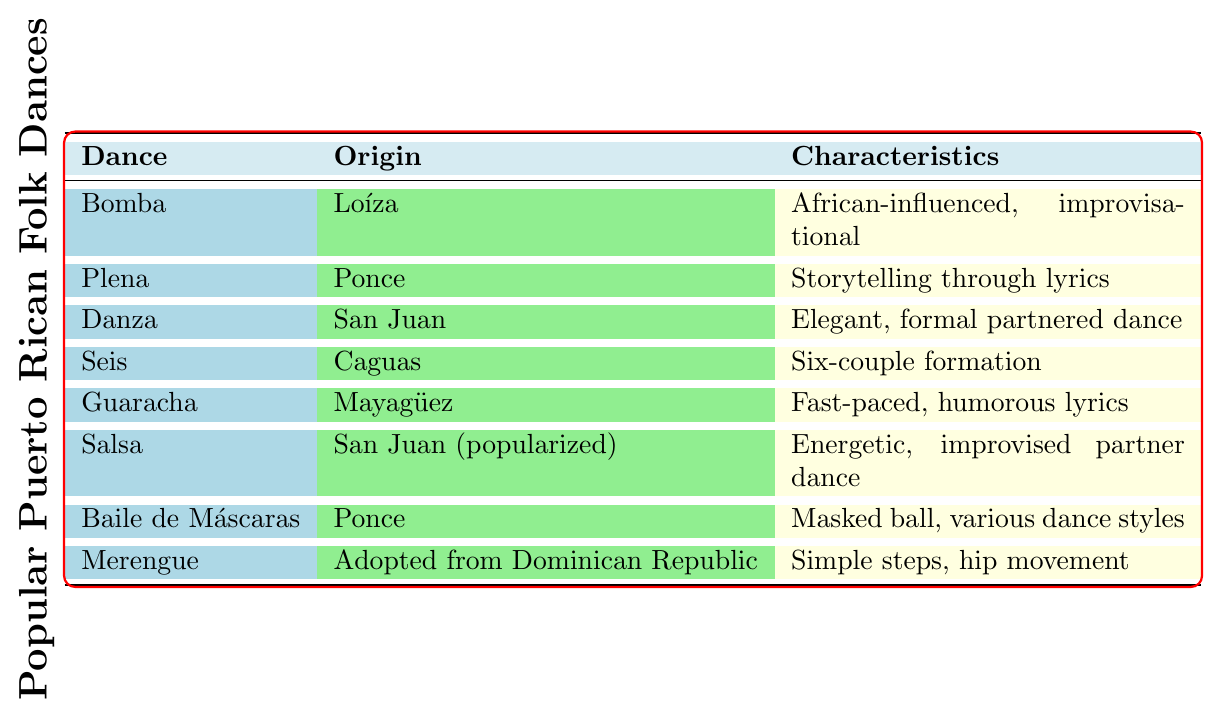What is the origin of Bomba? The table states that Bomba originates from Loíza.
Answer: Loíza What instruments are used in Plena? According to the table, Plena uses panderetas, güiro, and accordion.
Answer: Panderetas, güiro, accordion Which dance has storytelling through lyrics? The table indicates that Plena is characterized by storytelling through lyrics.
Answer: Plena Is Salsa a fusion of Cuban and Puerto Rican rhythms? The table confirms that Salsa is indeed a fusion of Cuban and Puerto Rican rhythms.
Answer: Yes What is the traditional costume for Guaracha? The table states that the traditional costume for Guaracha consists of colorful ruffled dresses and guayabera shirts.
Answer: Colorful ruffled dresses, guayabera shirts Which dance is known as Puerto Rico's national dance? The table specifies that Danza is recognized as Puerto Rico's national dance.
Answer: Danza How many dances originate from Ponce? From the table, we can see that there are two dances that originate from Ponce: Plena and Baile de Máscaras.
Answer: Two What is the main characteristic of Merengue? The table describes Merengue as having simple steps and hip movement.
Answer: Simple steps, hip movement Which dance involves a six-couple formation? Seis is the dance that features a six-couple formation, as indicated in the table.
Answer: Seis What can be inferred about the historical significance of Bomba? The table notes that Bomba was developed by enslaved Africans, suggesting its deep roots in African heritage and culture.
Answer: Developed by enslaved Africans How many instruments does Salsa use compared to Guaracha? The table lists Salsa as using four instruments (piano, timbales, conga, trumpet) and Guaracha as using three (timbales, bongos, trumpet). So, Salsa uses one more instrument than Guaracha.
Answer: One more instrument What do the traditional costumes of Bomba and Danza have in common? Both traditional costumes are formal, with Bomba being a white dress with colorful petticoats and Danza being formal attire with long dresses, showcasing elegance and cultural expression.
Answer: Both are formal attire 